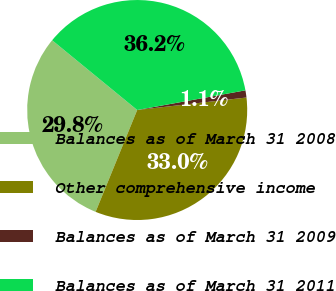Convert chart. <chart><loc_0><loc_0><loc_500><loc_500><pie_chart><fcel>Balances as of March 31 2008<fcel>Other comprehensive income<fcel>Balances as of March 31 2009<fcel>Balances as of March 31 2011<nl><fcel>29.76%<fcel>32.98%<fcel>1.05%<fcel>36.2%<nl></chart> 